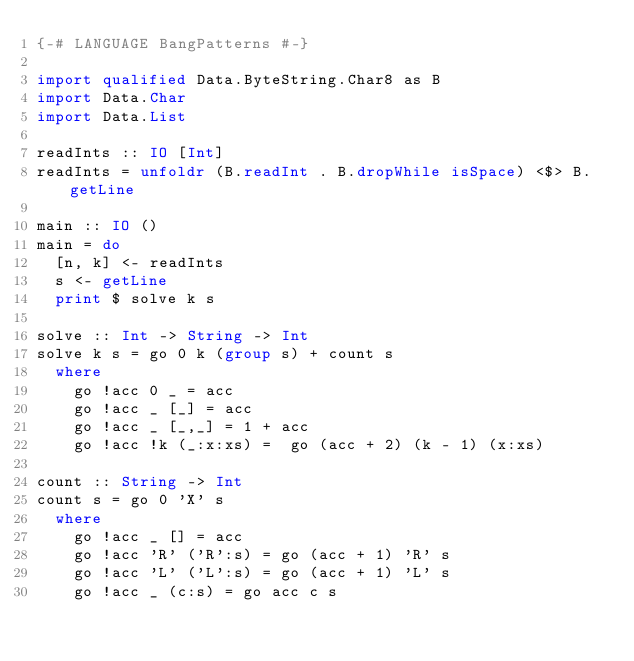Convert code to text. <code><loc_0><loc_0><loc_500><loc_500><_Haskell_>{-# LANGUAGE BangPatterns #-}

import qualified Data.ByteString.Char8 as B
import Data.Char
import Data.List

readInts :: IO [Int]
readInts = unfoldr (B.readInt . B.dropWhile isSpace) <$> B.getLine

main :: IO ()
main = do
  [n, k] <- readInts
  s <- getLine
  print $ solve k s

solve :: Int -> String -> Int
solve k s = go 0 k (group s) + count s
  where
    go !acc 0 _ = acc
    go !acc _ [_] = acc
    go !acc _ [_,_] = 1 + acc
    go !acc !k (_:x:xs) =  go (acc + 2) (k - 1) (x:xs)

count :: String -> Int
count s = go 0 'X' s
  where
    go !acc _ [] = acc
    go !acc 'R' ('R':s) = go (acc + 1) 'R' s
    go !acc 'L' ('L':s) = go (acc + 1) 'L' s
    go !acc _ (c:s) = go acc c s
</code> 